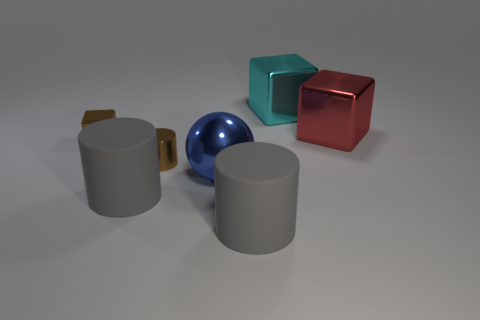There is a cube left of the big gray thing right of the blue sphere; how big is it? The cube to the left of the larger of the two gray cylinders and to the right of the blue sphere appears to be medium-sized relative to the other objects in the image. 